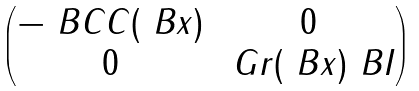<formula> <loc_0><loc_0><loc_500><loc_500>\begin{pmatrix} - \ B C C ( \ B x ) & 0 \\ 0 & \ G r ( \ B x ) \ B I \end{pmatrix}</formula> 